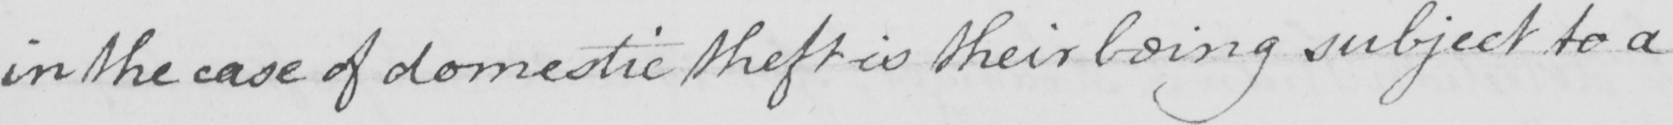Can you read and transcribe this handwriting? in the case of domestic theft is their being subject to a 